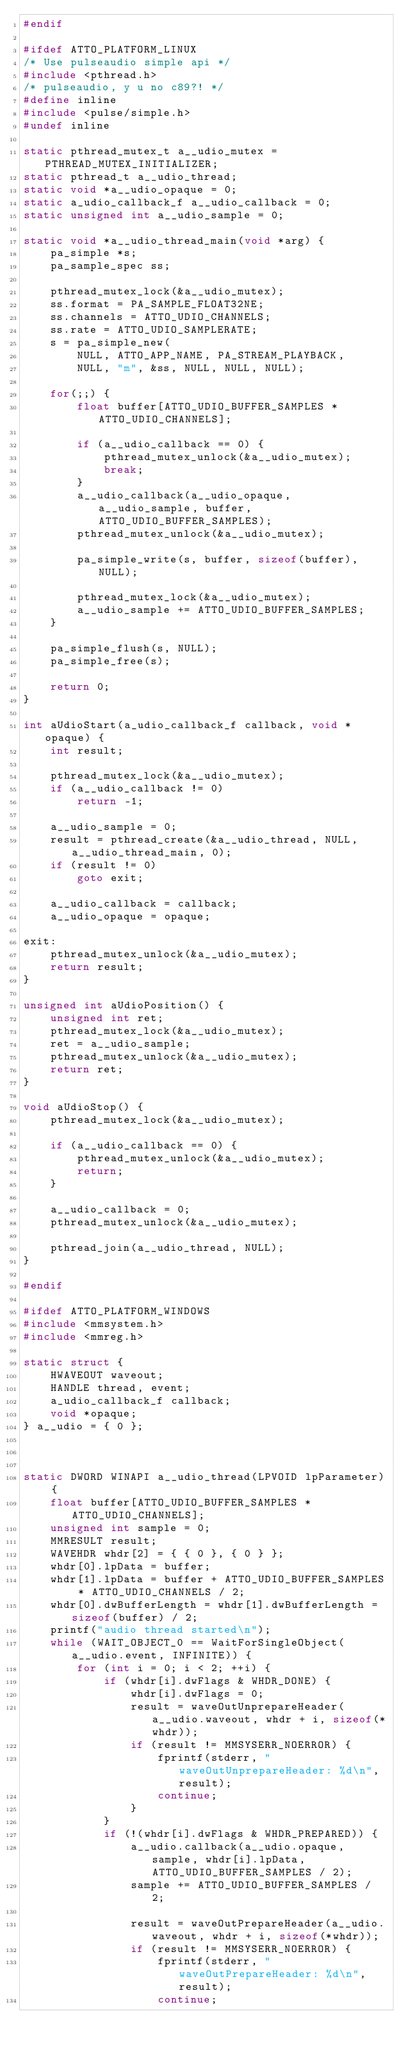Convert code to text. <code><loc_0><loc_0><loc_500><loc_500><_C_>#endif

#ifdef ATTO_PLATFORM_LINUX
/* Use pulseaudio simple api */
#include <pthread.h>
/* pulseaudio, y u no c89?! */
#define inline
#include <pulse/simple.h>
#undef inline

static pthread_mutex_t a__udio_mutex = PTHREAD_MUTEX_INITIALIZER;
static pthread_t a__udio_thread;
static void *a__udio_opaque = 0;
static a_udio_callback_f a__udio_callback = 0;
static unsigned int a__udio_sample = 0;

static void *a__udio_thread_main(void *arg) {
	pa_simple *s;
	pa_sample_spec ss;

	pthread_mutex_lock(&a__udio_mutex);
	ss.format = PA_SAMPLE_FLOAT32NE;
	ss.channels = ATTO_UDIO_CHANNELS;
	ss.rate = ATTO_UDIO_SAMPLERATE;
	s = pa_simple_new(
		NULL, ATTO_APP_NAME, PA_STREAM_PLAYBACK,
		NULL, "m", &ss, NULL, NULL, NULL);

	for(;;) {
		float buffer[ATTO_UDIO_BUFFER_SAMPLES * ATTO_UDIO_CHANNELS];

		if (a__udio_callback == 0) {
			pthread_mutex_unlock(&a__udio_mutex);
			break;
		}
		a__udio_callback(a__udio_opaque, a__udio_sample, buffer, ATTO_UDIO_BUFFER_SAMPLES);
		pthread_mutex_unlock(&a__udio_mutex);

		pa_simple_write(s, buffer, sizeof(buffer), NULL);

		pthread_mutex_lock(&a__udio_mutex);
		a__udio_sample += ATTO_UDIO_BUFFER_SAMPLES;
	}

	pa_simple_flush(s, NULL);
	pa_simple_free(s);

	return 0;
}

int aUdioStart(a_udio_callback_f callback, void *opaque) {
	int result;

	pthread_mutex_lock(&a__udio_mutex);
	if (a__udio_callback != 0)
		return -1;

	a__udio_sample = 0;
	result = pthread_create(&a__udio_thread, NULL, a__udio_thread_main, 0);
	if (result != 0)
		goto exit;

	a__udio_callback = callback;
	a__udio_opaque = opaque;

exit:
	pthread_mutex_unlock(&a__udio_mutex);
	return result;
}

unsigned int aUdioPosition() {
	unsigned int ret;
	pthread_mutex_lock(&a__udio_mutex);
	ret = a__udio_sample;
	pthread_mutex_unlock(&a__udio_mutex);
	return ret;
}

void aUdioStop() {
	pthread_mutex_lock(&a__udio_mutex);

	if (a__udio_callback == 0) {
		pthread_mutex_unlock(&a__udio_mutex);
		return;
	}

	a__udio_callback = 0;
	pthread_mutex_unlock(&a__udio_mutex);

	pthread_join(a__udio_thread, NULL);
}

#endif

#ifdef ATTO_PLATFORM_WINDOWS
#include <mmsystem.h>
#include <mmreg.h>

static struct {
	HWAVEOUT waveout;
	HANDLE thread, event;
	a_udio_callback_f callback;
	void *opaque;
} a__udio = { 0 };



static DWORD WINAPI a__udio_thread(LPVOID lpParameter) {
	float buffer[ATTO_UDIO_BUFFER_SAMPLES * ATTO_UDIO_CHANNELS];
	unsigned int sample = 0;
	MMRESULT result;
	WAVEHDR whdr[2] = { { 0 }, { 0 } };
	whdr[0].lpData = buffer;
	whdr[1].lpData = buffer + ATTO_UDIO_BUFFER_SAMPLES * ATTO_UDIO_CHANNELS / 2;
	whdr[0].dwBufferLength = whdr[1].dwBufferLength = sizeof(buffer) / 2;
	printf("audio thread started\n");
	while (WAIT_OBJECT_0 == WaitForSingleObject(a__udio.event, INFINITE)) {
		for (int i = 0; i < 2; ++i) {
			if (whdr[i].dwFlags & WHDR_DONE) {
				whdr[i].dwFlags = 0;
				result = waveOutUnprepareHeader(a__udio.waveout, whdr + i, sizeof(*whdr));
				if (result != MMSYSERR_NOERROR) {
					fprintf(stderr, "waveOutUnprepareHeader: %d\n", result);
					continue;
				}
			}
			if (!(whdr[i].dwFlags & WHDR_PREPARED)) {
				a__udio.callback(a__udio.opaque, sample, whdr[i].lpData, ATTO_UDIO_BUFFER_SAMPLES / 2);
				sample += ATTO_UDIO_BUFFER_SAMPLES / 2;

				result = waveOutPrepareHeader(a__udio.waveout, whdr + i, sizeof(*whdr));
				if (result != MMSYSERR_NOERROR) {
					fprintf(stderr, "waveOutPrepareHeader: %d\n", result);
					continue;</code> 